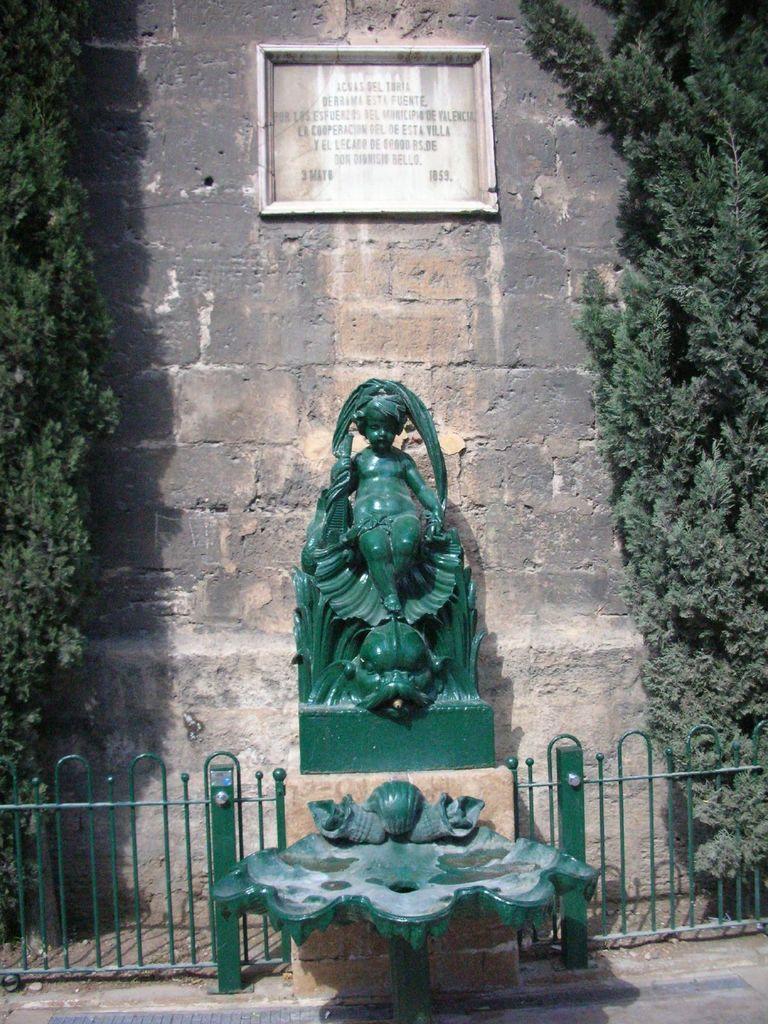Can you describe this image briefly? In this image there is a railing, in the middle there is an object, behind the railing there is a sculpture, on either side of a sculpture there are trees, in the background there is a wall. 